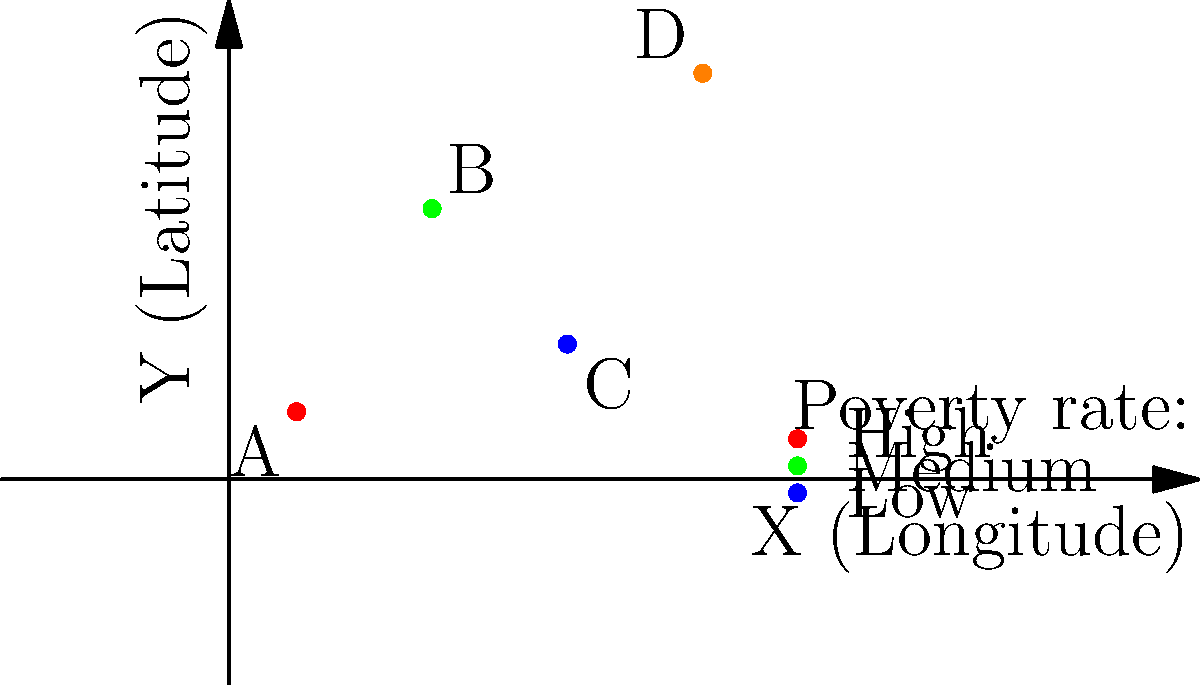Based on the 2D map showing poverty rates across different regions, which region has the highest poverty rate and what are its approximate coordinates? To answer this question, we need to analyze the given 2D map:

1. The map shows four regions (A, B, C, and D) plotted on a coordinate system.
2. Each region is represented by a colored dot.
3. According to the legend:
   - Red indicates a high poverty rate
   - Green indicates a medium poverty rate
   - Blue indicates a low poverty rate

4. Examining the map:
   - Region A is represented by a red dot, indicating the highest poverty rate.
   - Region B is represented by a green dot (medium poverty rate).
   - Region C is represented by a blue dot (low poverty rate).
   - Region D is represented by an orange dot (not specified in the legend, but likely between medium and high).

5. Region A has the highest poverty rate.

6. To determine the approximate coordinates of Region A:
   - The x-coordinate (longitude) is approximately 0.5
   - The y-coordinate (latitude) is approximately 0.5

Therefore, Region A has the highest poverty rate with approximate coordinates (0.5, 0.5).
Answer: Region A, coordinates (0.5, 0.5) 